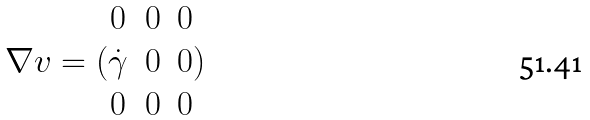<formula> <loc_0><loc_0><loc_500><loc_500>\nabla v = ( \begin{matrix} 0 & 0 & 0 \\ \dot { \gamma } & 0 & 0 \\ 0 & 0 & 0 \end{matrix} )</formula> 